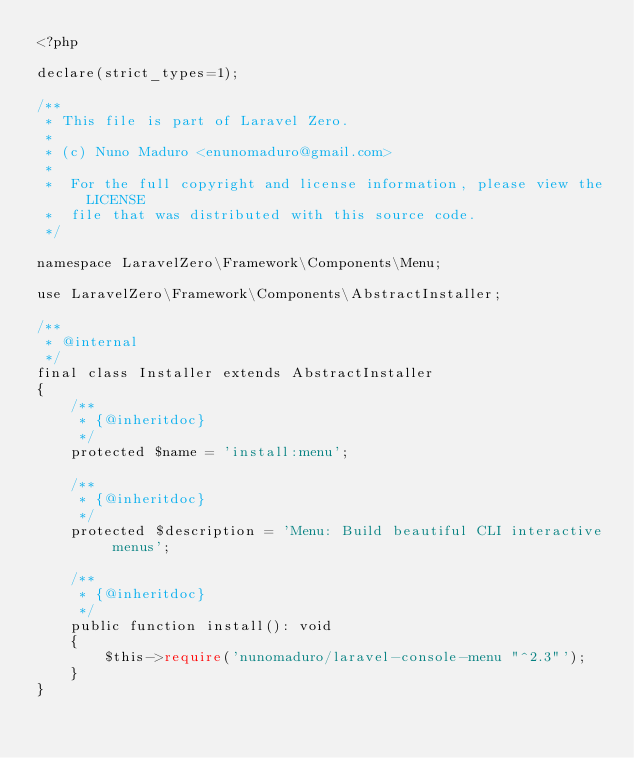Convert code to text. <code><loc_0><loc_0><loc_500><loc_500><_PHP_><?php

declare(strict_types=1);

/**
 * This file is part of Laravel Zero.
 *
 * (c) Nuno Maduro <enunomaduro@gmail.com>
 *
 *  For the full copyright and license information, please view the LICENSE
 *  file that was distributed with this source code.
 */

namespace LaravelZero\Framework\Components\Menu;

use LaravelZero\Framework\Components\AbstractInstaller;

/**
 * @internal
 */
final class Installer extends AbstractInstaller
{
    /**
     * {@inheritdoc}
     */
    protected $name = 'install:menu';

    /**
     * {@inheritdoc}
     */
    protected $description = 'Menu: Build beautiful CLI interactive menus';

    /**
     * {@inheritdoc}
     */
    public function install(): void
    {
        $this->require('nunomaduro/laravel-console-menu "^2.3"');
    }
}
</code> 